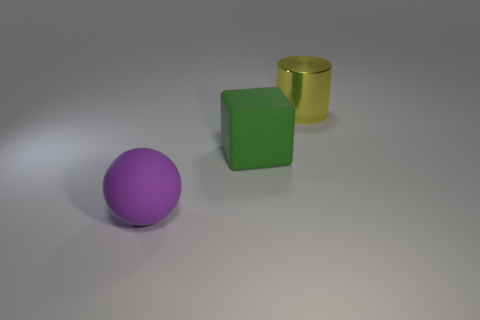There is a rubber object on the right side of the big sphere; what size is it?
Give a very brief answer. Large. Is the shape of the large object that is to the right of the big cube the same as  the large green object?
Offer a terse response. No. Are there any other things that are the same size as the yellow metallic cylinder?
Your answer should be very brief. Yes. Is there a tiny cyan rubber block?
Ensure brevity in your answer.  No. What is the material of the thing that is right of the big rubber thing that is on the right side of the large thing in front of the large green thing?
Provide a short and direct response. Metal. Does the purple rubber thing have the same shape as the large rubber object that is right of the big matte ball?
Offer a terse response. No. The big yellow metallic object has what shape?
Ensure brevity in your answer.  Cylinder. How big is the matte object behind the big purple ball that is in front of the green object?
Ensure brevity in your answer.  Large. How many things are large green matte things or big objects?
Make the answer very short. 3. Is the shape of the purple rubber thing the same as the big yellow metal object?
Your answer should be compact. No. 